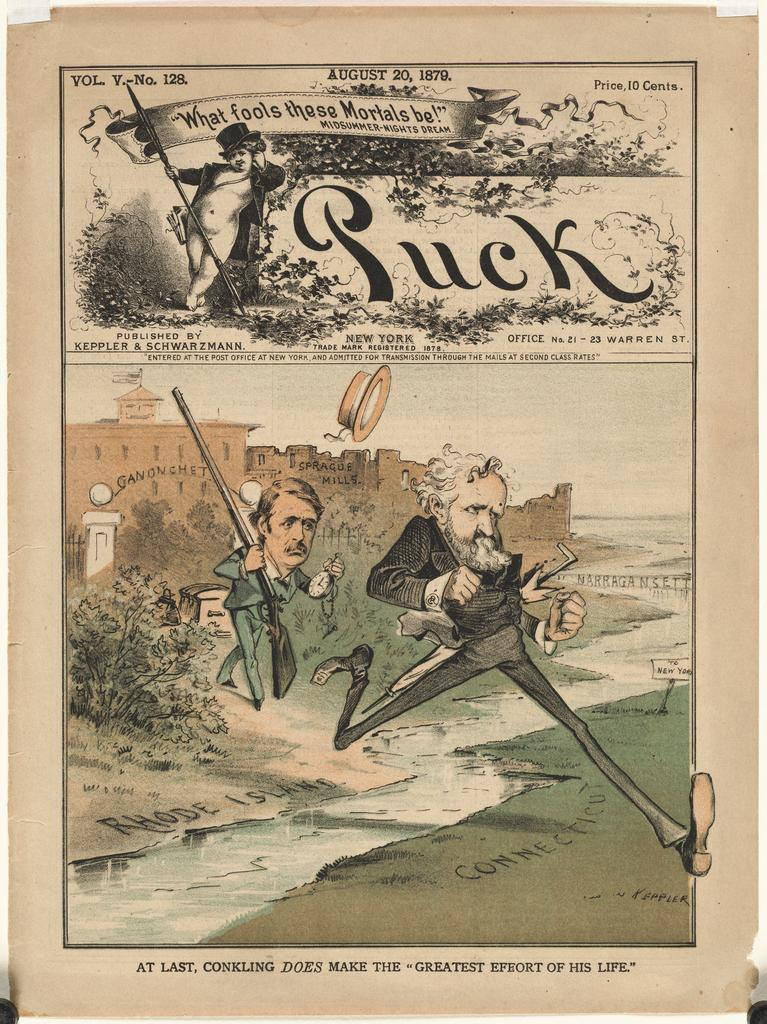<image>
Describe the image concisely. a magazine page dated August 20, 1879 and priced for 10 cents 